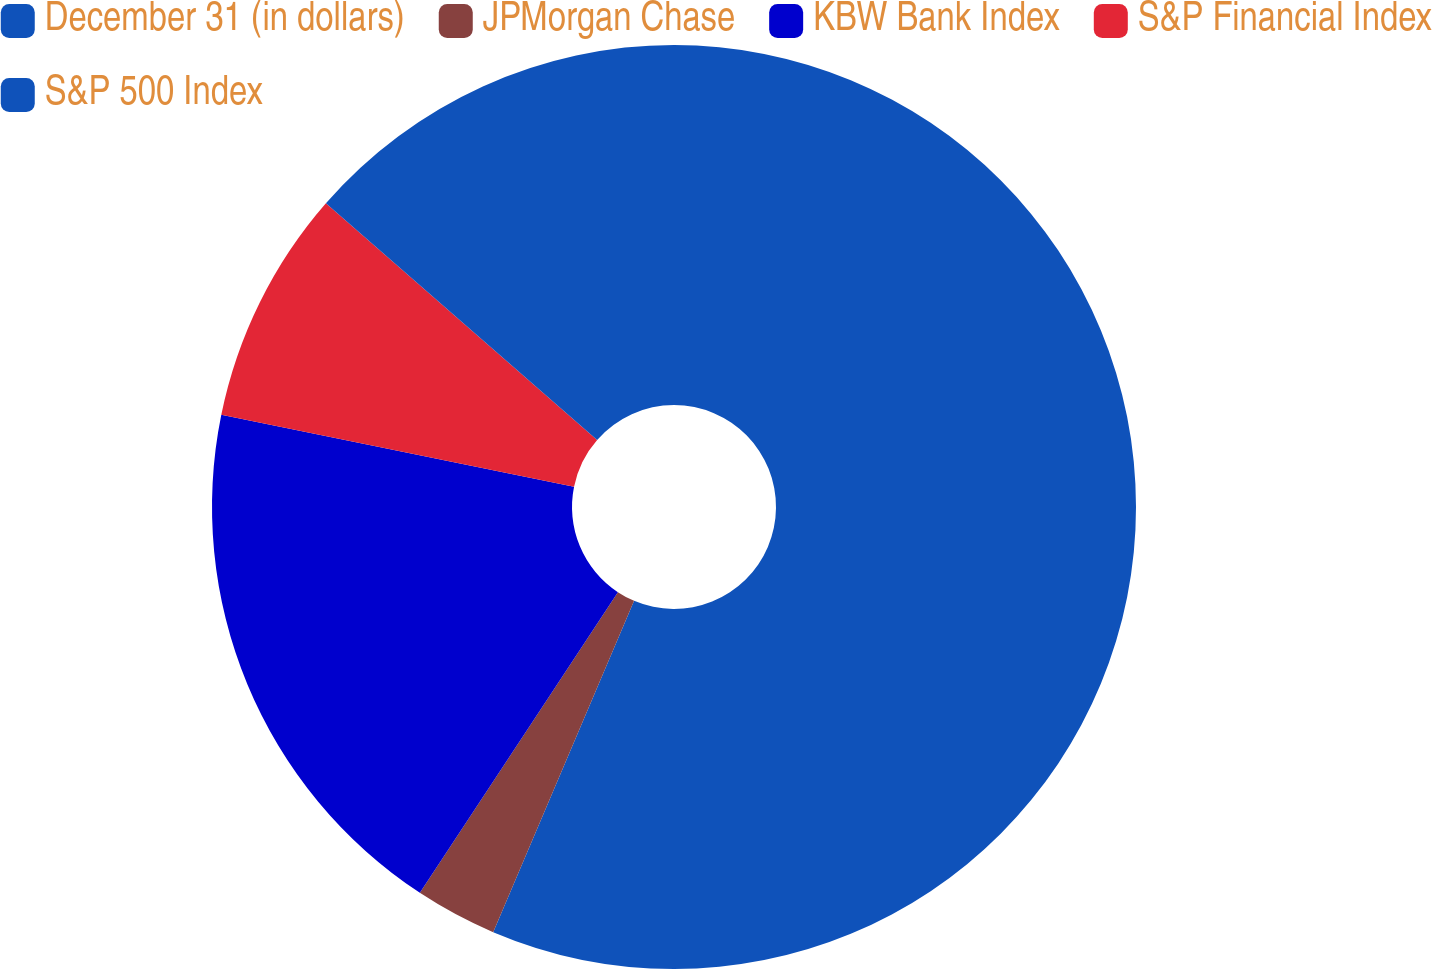Convert chart to OTSL. <chart><loc_0><loc_0><loc_500><loc_500><pie_chart><fcel>December 31 (in dollars)<fcel>JPMorgan Chase<fcel>KBW Bank Index<fcel>S&P Financial Index<fcel>S&P 500 Index<nl><fcel>56.4%<fcel>2.87%<fcel>18.93%<fcel>8.22%<fcel>13.58%<nl></chart> 